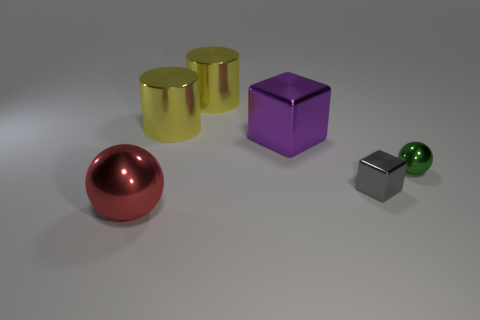Add 1 purple rubber cubes. How many objects exist? 7 Subtract all cylinders. How many objects are left? 4 Subtract 0 cyan cylinders. How many objects are left? 6 Subtract all gray shiny cubes. Subtract all tiny metallic cubes. How many objects are left? 4 Add 3 purple things. How many purple things are left? 4 Add 4 large objects. How many large objects exist? 8 